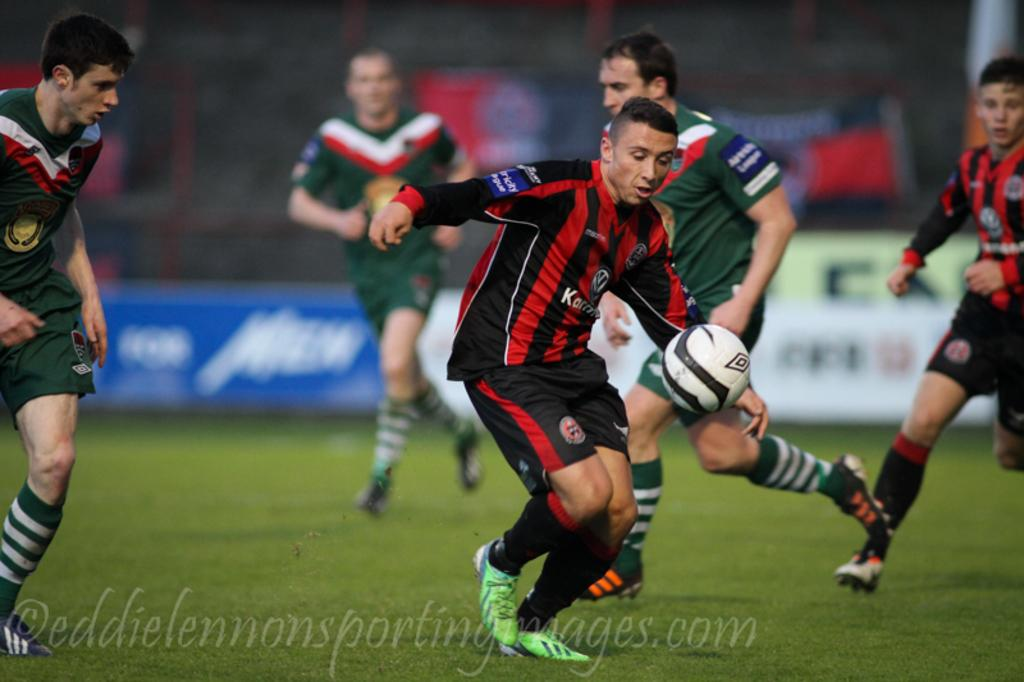What is the surface that the people are standing on in the image? The ground is covered with grass. What are the people doing on the grassy surface? The people are standing on the ground. What object can be seen in the air in the image? There is a football in the air. What type of lamp is being used for writing in the image? There is no lamp or writing present in the image; it features people standing on grassy ground with a football in the air. What is the desire of the people in the image? There is no indication of the people's desires in the image. 